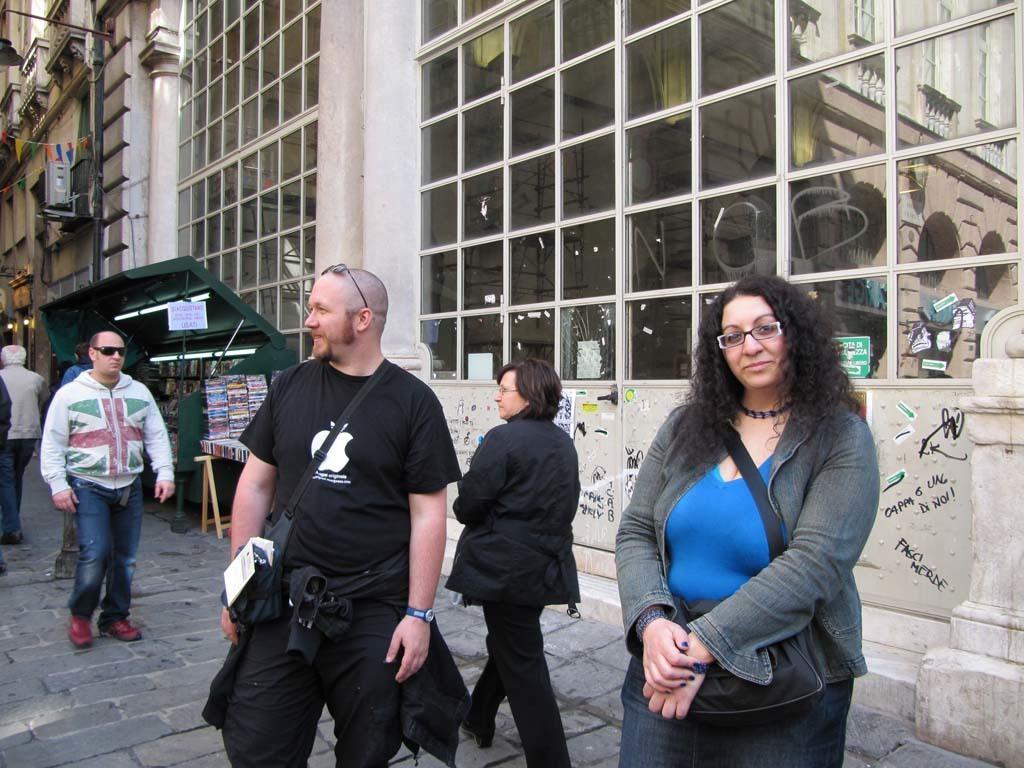Describe this image in one or two sentences. In this image, we can see a group of people. few are standing and walking on the platform. Here a woman is wearing a glass and seeing. Here woman and man are smiling. Background we can see glass, buildings, stalls, some objects, wall, stickers. On the glass, we can see some reflections. 